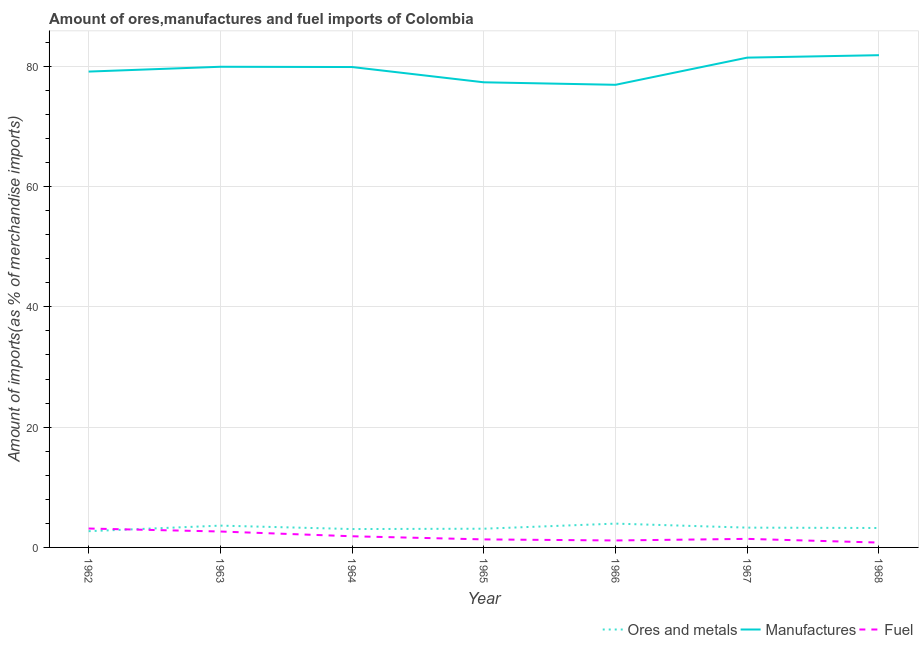How many different coloured lines are there?
Your response must be concise. 3. Does the line corresponding to percentage of fuel imports intersect with the line corresponding to percentage of manufactures imports?
Your response must be concise. No. What is the percentage of manufactures imports in 1967?
Give a very brief answer. 81.44. Across all years, what is the maximum percentage of manufactures imports?
Provide a short and direct response. 81.84. Across all years, what is the minimum percentage of manufactures imports?
Ensure brevity in your answer.  76.92. In which year was the percentage of ores and metals imports maximum?
Keep it short and to the point. 1966. In which year was the percentage of ores and metals imports minimum?
Your response must be concise. 1962. What is the total percentage of ores and metals imports in the graph?
Offer a very short reply. 22.97. What is the difference between the percentage of fuel imports in 1962 and that in 1964?
Give a very brief answer. 1.29. What is the difference between the percentage of ores and metals imports in 1962 and the percentage of manufactures imports in 1966?
Your answer should be very brief. -74.22. What is the average percentage of manufactures imports per year?
Your response must be concise. 79.49. In the year 1966, what is the difference between the percentage of fuel imports and percentage of manufactures imports?
Provide a short and direct response. -75.76. What is the ratio of the percentage of ores and metals imports in 1964 to that in 1966?
Your answer should be compact. 0.77. Is the percentage of fuel imports in 1962 less than that in 1965?
Provide a succinct answer. No. Is the difference between the percentage of ores and metals imports in 1964 and 1965 greater than the difference between the percentage of fuel imports in 1964 and 1965?
Ensure brevity in your answer.  No. What is the difference between the highest and the second highest percentage of manufactures imports?
Your response must be concise. 0.4. What is the difference between the highest and the lowest percentage of ores and metals imports?
Offer a very short reply. 1.26. How many lines are there?
Make the answer very short. 3. Does the graph contain grids?
Offer a terse response. Yes. How many legend labels are there?
Give a very brief answer. 3. What is the title of the graph?
Your response must be concise. Amount of ores,manufactures and fuel imports of Colombia. Does "Poland" appear as one of the legend labels in the graph?
Make the answer very short. No. What is the label or title of the Y-axis?
Provide a succinct answer. Amount of imports(as % of merchandise imports). What is the Amount of imports(as % of merchandise imports) in Ores and metals in 1962?
Keep it short and to the point. 2.7. What is the Amount of imports(as % of merchandise imports) in Manufactures in 1962?
Your answer should be compact. 79.12. What is the Amount of imports(as % of merchandise imports) in Fuel in 1962?
Provide a short and direct response. 3.14. What is the Amount of imports(as % of merchandise imports) in Ores and metals in 1963?
Keep it short and to the point. 3.63. What is the Amount of imports(as % of merchandise imports) in Manufactures in 1963?
Offer a terse response. 79.92. What is the Amount of imports(as % of merchandise imports) of Fuel in 1963?
Your answer should be very brief. 2.65. What is the Amount of imports(as % of merchandise imports) in Ores and metals in 1964?
Provide a short and direct response. 3.06. What is the Amount of imports(as % of merchandise imports) in Manufactures in 1964?
Offer a very short reply. 79.87. What is the Amount of imports(as % of merchandise imports) in Fuel in 1964?
Your response must be concise. 1.86. What is the Amount of imports(as % of merchandise imports) in Ores and metals in 1965?
Offer a terse response. 3.11. What is the Amount of imports(as % of merchandise imports) in Manufactures in 1965?
Provide a short and direct response. 77.33. What is the Amount of imports(as % of merchandise imports) of Fuel in 1965?
Provide a short and direct response. 1.33. What is the Amount of imports(as % of merchandise imports) of Ores and metals in 1966?
Give a very brief answer. 3.96. What is the Amount of imports(as % of merchandise imports) in Manufactures in 1966?
Your answer should be compact. 76.92. What is the Amount of imports(as % of merchandise imports) of Fuel in 1966?
Offer a terse response. 1.16. What is the Amount of imports(as % of merchandise imports) of Ores and metals in 1967?
Keep it short and to the point. 3.29. What is the Amount of imports(as % of merchandise imports) of Manufactures in 1967?
Provide a short and direct response. 81.44. What is the Amount of imports(as % of merchandise imports) of Fuel in 1967?
Provide a short and direct response. 1.42. What is the Amount of imports(as % of merchandise imports) in Ores and metals in 1968?
Provide a succinct answer. 3.23. What is the Amount of imports(as % of merchandise imports) in Manufactures in 1968?
Offer a very short reply. 81.84. What is the Amount of imports(as % of merchandise imports) of Fuel in 1968?
Offer a very short reply. 0.81. Across all years, what is the maximum Amount of imports(as % of merchandise imports) of Ores and metals?
Offer a terse response. 3.96. Across all years, what is the maximum Amount of imports(as % of merchandise imports) of Manufactures?
Offer a very short reply. 81.84. Across all years, what is the maximum Amount of imports(as % of merchandise imports) of Fuel?
Your response must be concise. 3.14. Across all years, what is the minimum Amount of imports(as % of merchandise imports) in Ores and metals?
Keep it short and to the point. 2.7. Across all years, what is the minimum Amount of imports(as % of merchandise imports) in Manufactures?
Provide a succinct answer. 76.92. Across all years, what is the minimum Amount of imports(as % of merchandise imports) of Fuel?
Provide a succinct answer. 0.81. What is the total Amount of imports(as % of merchandise imports) in Ores and metals in the graph?
Offer a very short reply. 22.97. What is the total Amount of imports(as % of merchandise imports) in Manufactures in the graph?
Provide a short and direct response. 556.45. What is the total Amount of imports(as % of merchandise imports) in Fuel in the graph?
Provide a succinct answer. 12.37. What is the difference between the Amount of imports(as % of merchandise imports) of Ores and metals in 1962 and that in 1963?
Your answer should be very brief. -0.92. What is the difference between the Amount of imports(as % of merchandise imports) in Manufactures in 1962 and that in 1963?
Your answer should be compact. -0.8. What is the difference between the Amount of imports(as % of merchandise imports) of Fuel in 1962 and that in 1963?
Your response must be concise. 0.5. What is the difference between the Amount of imports(as % of merchandise imports) in Ores and metals in 1962 and that in 1964?
Offer a terse response. -0.35. What is the difference between the Amount of imports(as % of merchandise imports) of Manufactures in 1962 and that in 1964?
Give a very brief answer. -0.76. What is the difference between the Amount of imports(as % of merchandise imports) of Fuel in 1962 and that in 1964?
Your answer should be compact. 1.29. What is the difference between the Amount of imports(as % of merchandise imports) in Ores and metals in 1962 and that in 1965?
Keep it short and to the point. -0.41. What is the difference between the Amount of imports(as % of merchandise imports) of Manufactures in 1962 and that in 1965?
Provide a short and direct response. 1.78. What is the difference between the Amount of imports(as % of merchandise imports) in Fuel in 1962 and that in 1965?
Offer a terse response. 1.81. What is the difference between the Amount of imports(as % of merchandise imports) in Ores and metals in 1962 and that in 1966?
Give a very brief answer. -1.26. What is the difference between the Amount of imports(as % of merchandise imports) in Manufactures in 1962 and that in 1966?
Your answer should be compact. 2.2. What is the difference between the Amount of imports(as % of merchandise imports) in Fuel in 1962 and that in 1966?
Offer a very short reply. 1.99. What is the difference between the Amount of imports(as % of merchandise imports) in Ores and metals in 1962 and that in 1967?
Offer a terse response. -0.59. What is the difference between the Amount of imports(as % of merchandise imports) in Manufactures in 1962 and that in 1967?
Provide a succinct answer. -2.32. What is the difference between the Amount of imports(as % of merchandise imports) of Fuel in 1962 and that in 1967?
Provide a succinct answer. 1.72. What is the difference between the Amount of imports(as % of merchandise imports) in Ores and metals in 1962 and that in 1968?
Ensure brevity in your answer.  -0.53. What is the difference between the Amount of imports(as % of merchandise imports) of Manufactures in 1962 and that in 1968?
Ensure brevity in your answer.  -2.72. What is the difference between the Amount of imports(as % of merchandise imports) in Fuel in 1962 and that in 1968?
Make the answer very short. 2.34. What is the difference between the Amount of imports(as % of merchandise imports) of Ores and metals in 1963 and that in 1964?
Keep it short and to the point. 0.57. What is the difference between the Amount of imports(as % of merchandise imports) of Manufactures in 1963 and that in 1964?
Ensure brevity in your answer.  0.04. What is the difference between the Amount of imports(as % of merchandise imports) of Fuel in 1963 and that in 1964?
Offer a very short reply. 0.79. What is the difference between the Amount of imports(as % of merchandise imports) of Ores and metals in 1963 and that in 1965?
Make the answer very short. 0.51. What is the difference between the Amount of imports(as % of merchandise imports) of Manufactures in 1963 and that in 1965?
Your answer should be compact. 2.58. What is the difference between the Amount of imports(as % of merchandise imports) in Fuel in 1963 and that in 1965?
Offer a very short reply. 1.31. What is the difference between the Amount of imports(as % of merchandise imports) of Ores and metals in 1963 and that in 1966?
Offer a terse response. -0.33. What is the difference between the Amount of imports(as % of merchandise imports) in Manufactures in 1963 and that in 1966?
Offer a very short reply. 3. What is the difference between the Amount of imports(as % of merchandise imports) in Fuel in 1963 and that in 1966?
Provide a succinct answer. 1.49. What is the difference between the Amount of imports(as % of merchandise imports) in Ores and metals in 1963 and that in 1967?
Your response must be concise. 0.34. What is the difference between the Amount of imports(as % of merchandise imports) of Manufactures in 1963 and that in 1967?
Ensure brevity in your answer.  -1.52. What is the difference between the Amount of imports(as % of merchandise imports) in Fuel in 1963 and that in 1967?
Your answer should be very brief. 1.22. What is the difference between the Amount of imports(as % of merchandise imports) in Ores and metals in 1963 and that in 1968?
Provide a short and direct response. 0.4. What is the difference between the Amount of imports(as % of merchandise imports) in Manufactures in 1963 and that in 1968?
Your answer should be very brief. -1.92. What is the difference between the Amount of imports(as % of merchandise imports) of Fuel in 1963 and that in 1968?
Provide a succinct answer. 1.84. What is the difference between the Amount of imports(as % of merchandise imports) of Ores and metals in 1964 and that in 1965?
Offer a very short reply. -0.06. What is the difference between the Amount of imports(as % of merchandise imports) in Manufactures in 1964 and that in 1965?
Provide a short and direct response. 2.54. What is the difference between the Amount of imports(as % of merchandise imports) in Fuel in 1964 and that in 1965?
Your answer should be very brief. 0.52. What is the difference between the Amount of imports(as % of merchandise imports) of Ores and metals in 1964 and that in 1966?
Provide a short and direct response. -0.9. What is the difference between the Amount of imports(as % of merchandise imports) of Manufactures in 1964 and that in 1966?
Your response must be concise. 2.95. What is the difference between the Amount of imports(as % of merchandise imports) in Fuel in 1964 and that in 1966?
Ensure brevity in your answer.  0.7. What is the difference between the Amount of imports(as % of merchandise imports) in Ores and metals in 1964 and that in 1967?
Provide a short and direct response. -0.23. What is the difference between the Amount of imports(as % of merchandise imports) in Manufactures in 1964 and that in 1967?
Ensure brevity in your answer.  -1.57. What is the difference between the Amount of imports(as % of merchandise imports) of Fuel in 1964 and that in 1967?
Keep it short and to the point. 0.43. What is the difference between the Amount of imports(as % of merchandise imports) of Ores and metals in 1964 and that in 1968?
Offer a terse response. -0.17. What is the difference between the Amount of imports(as % of merchandise imports) in Manufactures in 1964 and that in 1968?
Offer a terse response. -1.97. What is the difference between the Amount of imports(as % of merchandise imports) of Fuel in 1964 and that in 1968?
Your response must be concise. 1.05. What is the difference between the Amount of imports(as % of merchandise imports) in Ores and metals in 1965 and that in 1966?
Keep it short and to the point. -0.85. What is the difference between the Amount of imports(as % of merchandise imports) of Manufactures in 1965 and that in 1966?
Your response must be concise. 0.42. What is the difference between the Amount of imports(as % of merchandise imports) of Fuel in 1965 and that in 1966?
Your answer should be compact. 0.18. What is the difference between the Amount of imports(as % of merchandise imports) of Ores and metals in 1965 and that in 1967?
Provide a short and direct response. -0.18. What is the difference between the Amount of imports(as % of merchandise imports) of Manufactures in 1965 and that in 1967?
Make the answer very short. -4.1. What is the difference between the Amount of imports(as % of merchandise imports) in Fuel in 1965 and that in 1967?
Make the answer very short. -0.09. What is the difference between the Amount of imports(as % of merchandise imports) of Ores and metals in 1965 and that in 1968?
Your answer should be very brief. -0.12. What is the difference between the Amount of imports(as % of merchandise imports) in Manufactures in 1965 and that in 1968?
Give a very brief answer. -4.51. What is the difference between the Amount of imports(as % of merchandise imports) in Fuel in 1965 and that in 1968?
Offer a terse response. 0.53. What is the difference between the Amount of imports(as % of merchandise imports) in Ores and metals in 1966 and that in 1967?
Your response must be concise. 0.67. What is the difference between the Amount of imports(as % of merchandise imports) in Manufactures in 1966 and that in 1967?
Give a very brief answer. -4.52. What is the difference between the Amount of imports(as % of merchandise imports) in Fuel in 1966 and that in 1967?
Your answer should be compact. -0.27. What is the difference between the Amount of imports(as % of merchandise imports) in Ores and metals in 1966 and that in 1968?
Offer a very short reply. 0.73. What is the difference between the Amount of imports(as % of merchandise imports) of Manufactures in 1966 and that in 1968?
Provide a succinct answer. -4.92. What is the difference between the Amount of imports(as % of merchandise imports) of Fuel in 1966 and that in 1968?
Provide a short and direct response. 0.35. What is the difference between the Amount of imports(as % of merchandise imports) in Ores and metals in 1967 and that in 1968?
Provide a succinct answer. 0.06. What is the difference between the Amount of imports(as % of merchandise imports) of Manufactures in 1967 and that in 1968?
Give a very brief answer. -0.4. What is the difference between the Amount of imports(as % of merchandise imports) of Fuel in 1967 and that in 1968?
Provide a succinct answer. 0.62. What is the difference between the Amount of imports(as % of merchandise imports) of Ores and metals in 1962 and the Amount of imports(as % of merchandise imports) of Manufactures in 1963?
Your answer should be very brief. -77.22. What is the difference between the Amount of imports(as % of merchandise imports) of Ores and metals in 1962 and the Amount of imports(as % of merchandise imports) of Fuel in 1963?
Provide a short and direct response. 0.06. What is the difference between the Amount of imports(as % of merchandise imports) of Manufactures in 1962 and the Amount of imports(as % of merchandise imports) of Fuel in 1963?
Your answer should be very brief. 76.47. What is the difference between the Amount of imports(as % of merchandise imports) of Ores and metals in 1962 and the Amount of imports(as % of merchandise imports) of Manufactures in 1964?
Ensure brevity in your answer.  -77.17. What is the difference between the Amount of imports(as % of merchandise imports) of Ores and metals in 1962 and the Amount of imports(as % of merchandise imports) of Fuel in 1964?
Ensure brevity in your answer.  0.84. What is the difference between the Amount of imports(as % of merchandise imports) of Manufactures in 1962 and the Amount of imports(as % of merchandise imports) of Fuel in 1964?
Provide a short and direct response. 77.26. What is the difference between the Amount of imports(as % of merchandise imports) in Ores and metals in 1962 and the Amount of imports(as % of merchandise imports) in Manufactures in 1965?
Your answer should be compact. -74.63. What is the difference between the Amount of imports(as % of merchandise imports) of Ores and metals in 1962 and the Amount of imports(as % of merchandise imports) of Fuel in 1965?
Keep it short and to the point. 1.37. What is the difference between the Amount of imports(as % of merchandise imports) in Manufactures in 1962 and the Amount of imports(as % of merchandise imports) in Fuel in 1965?
Offer a terse response. 77.78. What is the difference between the Amount of imports(as % of merchandise imports) in Ores and metals in 1962 and the Amount of imports(as % of merchandise imports) in Manufactures in 1966?
Provide a short and direct response. -74.22. What is the difference between the Amount of imports(as % of merchandise imports) of Ores and metals in 1962 and the Amount of imports(as % of merchandise imports) of Fuel in 1966?
Provide a succinct answer. 1.54. What is the difference between the Amount of imports(as % of merchandise imports) in Manufactures in 1962 and the Amount of imports(as % of merchandise imports) in Fuel in 1966?
Make the answer very short. 77.96. What is the difference between the Amount of imports(as % of merchandise imports) of Ores and metals in 1962 and the Amount of imports(as % of merchandise imports) of Manufactures in 1967?
Your answer should be very brief. -78.74. What is the difference between the Amount of imports(as % of merchandise imports) in Ores and metals in 1962 and the Amount of imports(as % of merchandise imports) in Fuel in 1967?
Ensure brevity in your answer.  1.28. What is the difference between the Amount of imports(as % of merchandise imports) in Manufactures in 1962 and the Amount of imports(as % of merchandise imports) in Fuel in 1967?
Your response must be concise. 77.7. What is the difference between the Amount of imports(as % of merchandise imports) of Ores and metals in 1962 and the Amount of imports(as % of merchandise imports) of Manufactures in 1968?
Offer a very short reply. -79.14. What is the difference between the Amount of imports(as % of merchandise imports) in Ores and metals in 1962 and the Amount of imports(as % of merchandise imports) in Fuel in 1968?
Keep it short and to the point. 1.89. What is the difference between the Amount of imports(as % of merchandise imports) of Manufactures in 1962 and the Amount of imports(as % of merchandise imports) of Fuel in 1968?
Your answer should be compact. 78.31. What is the difference between the Amount of imports(as % of merchandise imports) in Ores and metals in 1963 and the Amount of imports(as % of merchandise imports) in Manufactures in 1964?
Make the answer very short. -76.25. What is the difference between the Amount of imports(as % of merchandise imports) of Ores and metals in 1963 and the Amount of imports(as % of merchandise imports) of Fuel in 1964?
Ensure brevity in your answer.  1.77. What is the difference between the Amount of imports(as % of merchandise imports) in Manufactures in 1963 and the Amount of imports(as % of merchandise imports) in Fuel in 1964?
Provide a short and direct response. 78.06. What is the difference between the Amount of imports(as % of merchandise imports) of Ores and metals in 1963 and the Amount of imports(as % of merchandise imports) of Manufactures in 1965?
Your answer should be very brief. -73.71. What is the difference between the Amount of imports(as % of merchandise imports) in Ores and metals in 1963 and the Amount of imports(as % of merchandise imports) in Fuel in 1965?
Give a very brief answer. 2.29. What is the difference between the Amount of imports(as % of merchandise imports) in Manufactures in 1963 and the Amount of imports(as % of merchandise imports) in Fuel in 1965?
Provide a short and direct response. 78.58. What is the difference between the Amount of imports(as % of merchandise imports) in Ores and metals in 1963 and the Amount of imports(as % of merchandise imports) in Manufactures in 1966?
Keep it short and to the point. -73.29. What is the difference between the Amount of imports(as % of merchandise imports) in Ores and metals in 1963 and the Amount of imports(as % of merchandise imports) in Fuel in 1966?
Keep it short and to the point. 2.47. What is the difference between the Amount of imports(as % of merchandise imports) in Manufactures in 1963 and the Amount of imports(as % of merchandise imports) in Fuel in 1966?
Provide a succinct answer. 78.76. What is the difference between the Amount of imports(as % of merchandise imports) of Ores and metals in 1963 and the Amount of imports(as % of merchandise imports) of Manufactures in 1967?
Offer a very short reply. -77.81. What is the difference between the Amount of imports(as % of merchandise imports) in Ores and metals in 1963 and the Amount of imports(as % of merchandise imports) in Fuel in 1967?
Make the answer very short. 2.2. What is the difference between the Amount of imports(as % of merchandise imports) of Manufactures in 1963 and the Amount of imports(as % of merchandise imports) of Fuel in 1967?
Make the answer very short. 78.5. What is the difference between the Amount of imports(as % of merchandise imports) of Ores and metals in 1963 and the Amount of imports(as % of merchandise imports) of Manufactures in 1968?
Provide a short and direct response. -78.22. What is the difference between the Amount of imports(as % of merchandise imports) in Ores and metals in 1963 and the Amount of imports(as % of merchandise imports) in Fuel in 1968?
Your answer should be compact. 2.82. What is the difference between the Amount of imports(as % of merchandise imports) in Manufactures in 1963 and the Amount of imports(as % of merchandise imports) in Fuel in 1968?
Offer a terse response. 79.11. What is the difference between the Amount of imports(as % of merchandise imports) in Ores and metals in 1964 and the Amount of imports(as % of merchandise imports) in Manufactures in 1965?
Offer a terse response. -74.28. What is the difference between the Amount of imports(as % of merchandise imports) in Ores and metals in 1964 and the Amount of imports(as % of merchandise imports) in Fuel in 1965?
Ensure brevity in your answer.  1.72. What is the difference between the Amount of imports(as % of merchandise imports) in Manufactures in 1964 and the Amount of imports(as % of merchandise imports) in Fuel in 1965?
Offer a terse response. 78.54. What is the difference between the Amount of imports(as % of merchandise imports) in Ores and metals in 1964 and the Amount of imports(as % of merchandise imports) in Manufactures in 1966?
Your answer should be very brief. -73.86. What is the difference between the Amount of imports(as % of merchandise imports) in Ores and metals in 1964 and the Amount of imports(as % of merchandise imports) in Fuel in 1966?
Make the answer very short. 1.9. What is the difference between the Amount of imports(as % of merchandise imports) of Manufactures in 1964 and the Amount of imports(as % of merchandise imports) of Fuel in 1966?
Provide a succinct answer. 78.72. What is the difference between the Amount of imports(as % of merchandise imports) of Ores and metals in 1964 and the Amount of imports(as % of merchandise imports) of Manufactures in 1967?
Your answer should be compact. -78.38. What is the difference between the Amount of imports(as % of merchandise imports) in Ores and metals in 1964 and the Amount of imports(as % of merchandise imports) in Fuel in 1967?
Provide a succinct answer. 1.63. What is the difference between the Amount of imports(as % of merchandise imports) of Manufactures in 1964 and the Amount of imports(as % of merchandise imports) of Fuel in 1967?
Your response must be concise. 78.45. What is the difference between the Amount of imports(as % of merchandise imports) in Ores and metals in 1964 and the Amount of imports(as % of merchandise imports) in Manufactures in 1968?
Provide a succinct answer. -78.79. What is the difference between the Amount of imports(as % of merchandise imports) in Ores and metals in 1964 and the Amount of imports(as % of merchandise imports) in Fuel in 1968?
Your answer should be very brief. 2.25. What is the difference between the Amount of imports(as % of merchandise imports) of Manufactures in 1964 and the Amount of imports(as % of merchandise imports) of Fuel in 1968?
Give a very brief answer. 79.07. What is the difference between the Amount of imports(as % of merchandise imports) of Ores and metals in 1965 and the Amount of imports(as % of merchandise imports) of Manufactures in 1966?
Ensure brevity in your answer.  -73.81. What is the difference between the Amount of imports(as % of merchandise imports) of Ores and metals in 1965 and the Amount of imports(as % of merchandise imports) of Fuel in 1966?
Make the answer very short. 1.95. What is the difference between the Amount of imports(as % of merchandise imports) in Manufactures in 1965 and the Amount of imports(as % of merchandise imports) in Fuel in 1966?
Keep it short and to the point. 76.18. What is the difference between the Amount of imports(as % of merchandise imports) in Ores and metals in 1965 and the Amount of imports(as % of merchandise imports) in Manufactures in 1967?
Offer a terse response. -78.33. What is the difference between the Amount of imports(as % of merchandise imports) of Ores and metals in 1965 and the Amount of imports(as % of merchandise imports) of Fuel in 1967?
Provide a succinct answer. 1.69. What is the difference between the Amount of imports(as % of merchandise imports) of Manufactures in 1965 and the Amount of imports(as % of merchandise imports) of Fuel in 1967?
Offer a terse response. 75.91. What is the difference between the Amount of imports(as % of merchandise imports) of Ores and metals in 1965 and the Amount of imports(as % of merchandise imports) of Manufactures in 1968?
Provide a short and direct response. -78.73. What is the difference between the Amount of imports(as % of merchandise imports) of Ores and metals in 1965 and the Amount of imports(as % of merchandise imports) of Fuel in 1968?
Your answer should be very brief. 2.3. What is the difference between the Amount of imports(as % of merchandise imports) of Manufactures in 1965 and the Amount of imports(as % of merchandise imports) of Fuel in 1968?
Provide a short and direct response. 76.53. What is the difference between the Amount of imports(as % of merchandise imports) in Ores and metals in 1966 and the Amount of imports(as % of merchandise imports) in Manufactures in 1967?
Make the answer very short. -77.48. What is the difference between the Amount of imports(as % of merchandise imports) of Ores and metals in 1966 and the Amount of imports(as % of merchandise imports) of Fuel in 1967?
Offer a very short reply. 2.54. What is the difference between the Amount of imports(as % of merchandise imports) of Manufactures in 1966 and the Amount of imports(as % of merchandise imports) of Fuel in 1967?
Your answer should be compact. 75.5. What is the difference between the Amount of imports(as % of merchandise imports) of Ores and metals in 1966 and the Amount of imports(as % of merchandise imports) of Manufactures in 1968?
Make the answer very short. -77.88. What is the difference between the Amount of imports(as % of merchandise imports) of Ores and metals in 1966 and the Amount of imports(as % of merchandise imports) of Fuel in 1968?
Your answer should be very brief. 3.15. What is the difference between the Amount of imports(as % of merchandise imports) in Manufactures in 1966 and the Amount of imports(as % of merchandise imports) in Fuel in 1968?
Make the answer very short. 76.11. What is the difference between the Amount of imports(as % of merchandise imports) of Ores and metals in 1967 and the Amount of imports(as % of merchandise imports) of Manufactures in 1968?
Ensure brevity in your answer.  -78.55. What is the difference between the Amount of imports(as % of merchandise imports) in Ores and metals in 1967 and the Amount of imports(as % of merchandise imports) in Fuel in 1968?
Ensure brevity in your answer.  2.48. What is the difference between the Amount of imports(as % of merchandise imports) in Manufactures in 1967 and the Amount of imports(as % of merchandise imports) in Fuel in 1968?
Your response must be concise. 80.63. What is the average Amount of imports(as % of merchandise imports) in Ores and metals per year?
Your answer should be compact. 3.28. What is the average Amount of imports(as % of merchandise imports) in Manufactures per year?
Your response must be concise. 79.49. What is the average Amount of imports(as % of merchandise imports) of Fuel per year?
Your answer should be compact. 1.77. In the year 1962, what is the difference between the Amount of imports(as % of merchandise imports) of Ores and metals and Amount of imports(as % of merchandise imports) of Manufactures?
Keep it short and to the point. -76.42. In the year 1962, what is the difference between the Amount of imports(as % of merchandise imports) in Ores and metals and Amount of imports(as % of merchandise imports) in Fuel?
Provide a short and direct response. -0.44. In the year 1962, what is the difference between the Amount of imports(as % of merchandise imports) in Manufactures and Amount of imports(as % of merchandise imports) in Fuel?
Your answer should be compact. 75.98. In the year 1963, what is the difference between the Amount of imports(as % of merchandise imports) of Ores and metals and Amount of imports(as % of merchandise imports) of Manufactures?
Offer a terse response. -76.29. In the year 1963, what is the difference between the Amount of imports(as % of merchandise imports) of Ores and metals and Amount of imports(as % of merchandise imports) of Fuel?
Keep it short and to the point. 0.98. In the year 1963, what is the difference between the Amount of imports(as % of merchandise imports) of Manufactures and Amount of imports(as % of merchandise imports) of Fuel?
Keep it short and to the point. 77.27. In the year 1964, what is the difference between the Amount of imports(as % of merchandise imports) of Ores and metals and Amount of imports(as % of merchandise imports) of Manufactures?
Give a very brief answer. -76.82. In the year 1964, what is the difference between the Amount of imports(as % of merchandise imports) of Ores and metals and Amount of imports(as % of merchandise imports) of Fuel?
Make the answer very short. 1.2. In the year 1964, what is the difference between the Amount of imports(as % of merchandise imports) of Manufactures and Amount of imports(as % of merchandise imports) of Fuel?
Offer a terse response. 78.02. In the year 1965, what is the difference between the Amount of imports(as % of merchandise imports) in Ores and metals and Amount of imports(as % of merchandise imports) in Manufactures?
Your answer should be very brief. -74.22. In the year 1965, what is the difference between the Amount of imports(as % of merchandise imports) of Ores and metals and Amount of imports(as % of merchandise imports) of Fuel?
Provide a short and direct response. 1.78. In the year 1965, what is the difference between the Amount of imports(as % of merchandise imports) in Manufactures and Amount of imports(as % of merchandise imports) in Fuel?
Give a very brief answer. 76. In the year 1966, what is the difference between the Amount of imports(as % of merchandise imports) of Ores and metals and Amount of imports(as % of merchandise imports) of Manufactures?
Your answer should be compact. -72.96. In the year 1966, what is the difference between the Amount of imports(as % of merchandise imports) in Ores and metals and Amount of imports(as % of merchandise imports) in Fuel?
Keep it short and to the point. 2.8. In the year 1966, what is the difference between the Amount of imports(as % of merchandise imports) of Manufactures and Amount of imports(as % of merchandise imports) of Fuel?
Make the answer very short. 75.76. In the year 1967, what is the difference between the Amount of imports(as % of merchandise imports) of Ores and metals and Amount of imports(as % of merchandise imports) of Manufactures?
Give a very brief answer. -78.15. In the year 1967, what is the difference between the Amount of imports(as % of merchandise imports) in Ores and metals and Amount of imports(as % of merchandise imports) in Fuel?
Offer a terse response. 1.87. In the year 1967, what is the difference between the Amount of imports(as % of merchandise imports) of Manufactures and Amount of imports(as % of merchandise imports) of Fuel?
Keep it short and to the point. 80.02. In the year 1968, what is the difference between the Amount of imports(as % of merchandise imports) of Ores and metals and Amount of imports(as % of merchandise imports) of Manufactures?
Provide a short and direct response. -78.61. In the year 1968, what is the difference between the Amount of imports(as % of merchandise imports) in Ores and metals and Amount of imports(as % of merchandise imports) in Fuel?
Offer a terse response. 2.42. In the year 1968, what is the difference between the Amount of imports(as % of merchandise imports) in Manufactures and Amount of imports(as % of merchandise imports) in Fuel?
Offer a very short reply. 81.04. What is the ratio of the Amount of imports(as % of merchandise imports) of Ores and metals in 1962 to that in 1963?
Offer a very short reply. 0.75. What is the ratio of the Amount of imports(as % of merchandise imports) of Fuel in 1962 to that in 1963?
Your answer should be very brief. 1.19. What is the ratio of the Amount of imports(as % of merchandise imports) of Ores and metals in 1962 to that in 1964?
Your answer should be very brief. 0.88. What is the ratio of the Amount of imports(as % of merchandise imports) in Manufactures in 1962 to that in 1964?
Offer a terse response. 0.99. What is the ratio of the Amount of imports(as % of merchandise imports) in Fuel in 1962 to that in 1964?
Your answer should be very brief. 1.69. What is the ratio of the Amount of imports(as % of merchandise imports) in Ores and metals in 1962 to that in 1965?
Provide a short and direct response. 0.87. What is the ratio of the Amount of imports(as % of merchandise imports) in Manufactures in 1962 to that in 1965?
Your answer should be very brief. 1.02. What is the ratio of the Amount of imports(as % of merchandise imports) of Fuel in 1962 to that in 1965?
Offer a very short reply. 2.36. What is the ratio of the Amount of imports(as % of merchandise imports) in Ores and metals in 1962 to that in 1966?
Provide a short and direct response. 0.68. What is the ratio of the Amount of imports(as % of merchandise imports) of Manufactures in 1962 to that in 1966?
Keep it short and to the point. 1.03. What is the ratio of the Amount of imports(as % of merchandise imports) of Fuel in 1962 to that in 1966?
Keep it short and to the point. 2.72. What is the ratio of the Amount of imports(as % of merchandise imports) in Ores and metals in 1962 to that in 1967?
Your answer should be compact. 0.82. What is the ratio of the Amount of imports(as % of merchandise imports) of Manufactures in 1962 to that in 1967?
Provide a succinct answer. 0.97. What is the ratio of the Amount of imports(as % of merchandise imports) in Fuel in 1962 to that in 1967?
Provide a succinct answer. 2.21. What is the ratio of the Amount of imports(as % of merchandise imports) of Ores and metals in 1962 to that in 1968?
Offer a very short reply. 0.84. What is the ratio of the Amount of imports(as % of merchandise imports) of Manufactures in 1962 to that in 1968?
Keep it short and to the point. 0.97. What is the ratio of the Amount of imports(as % of merchandise imports) of Fuel in 1962 to that in 1968?
Offer a very short reply. 3.9. What is the ratio of the Amount of imports(as % of merchandise imports) of Ores and metals in 1963 to that in 1964?
Your response must be concise. 1.19. What is the ratio of the Amount of imports(as % of merchandise imports) in Fuel in 1963 to that in 1964?
Ensure brevity in your answer.  1.43. What is the ratio of the Amount of imports(as % of merchandise imports) in Ores and metals in 1963 to that in 1965?
Provide a succinct answer. 1.17. What is the ratio of the Amount of imports(as % of merchandise imports) of Manufactures in 1963 to that in 1965?
Give a very brief answer. 1.03. What is the ratio of the Amount of imports(as % of merchandise imports) of Fuel in 1963 to that in 1965?
Keep it short and to the point. 1.98. What is the ratio of the Amount of imports(as % of merchandise imports) in Ores and metals in 1963 to that in 1966?
Offer a very short reply. 0.92. What is the ratio of the Amount of imports(as % of merchandise imports) in Manufactures in 1963 to that in 1966?
Make the answer very short. 1.04. What is the ratio of the Amount of imports(as % of merchandise imports) of Fuel in 1963 to that in 1966?
Offer a very short reply. 2.29. What is the ratio of the Amount of imports(as % of merchandise imports) in Ores and metals in 1963 to that in 1967?
Your answer should be compact. 1.1. What is the ratio of the Amount of imports(as % of merchandise imports) of Manufactures in 1963 to that in 1967?
Your answer should be very brief. 0.98. What is the ratio of the Amount of imports(as % of merchandise imports) in Fuel in 1963 to that in 1967?
Give a very brief answer. 1.86. What is the ratio of the Amount of imports(as % of merchandise imports) of Ores and metals in 1963 to that in 1968?
Provide a succinct answer. 1.12. What is the ratio of the Amount of imports(as % of merchandise imports) of Manufactures in 1963 to that in 1968?
Ensure brevity in your answer.  0.98. What is the ratio of the Amount of imports(as % of merchandise imports) of Fuel in 1963 to that in 1968?
Provide a succinct answer. 3.28. What is the ratio of the Amount of imports(as % of merchandise imports) of Ores and metals in 1964 to that in 1965?
Offer a terse response. 0.98. What is the ratio of the Amount of imports(as % of merchandise imports) of Manufactures in 1964 to that in 1965?
Your answer should be compact. 1.03. What is the ratio of the Amount of imports(as % of merchandise imports) of Fuel in 1964 to that in 1965?
Provide a short and direct response. 1.39. What is the ratio of the Amount of imports(as % of merchandise imports) of Ores and metals in 1964 to that in 1966?
Offer a terse response. 0.77. What is the ratio of the Amount of imports(as % of merchandise imports) in Manufactures in 1964 to that in 1966?
Your answer should be compact. 1.04. What is the ratio of the Amount of imports(as % of merchandise imports) in Fuel in 1964 to that in 1966?
Offer a terse response. 1.6. What is the ratio of the Amount of imports(as % of merchandise imports) in Ores and metals in 1964 to that in 1967?
Offer a very short reply. 0.93. What is the ratio of the Amount of imports(as % of merchandise imports) of Manufactures in 1964 to that in 1967?
Provide a short and direct response. 0.98. What is the ratio of the Amount of imports(as % of merchandise imports) in Fuel in 1964 to that in 1967?
Ensure brevity in your answer.  1.3. What is the ratio of the Amount of imports(as % of merchandise imports) of Ores and metals in 1964 to that in 1968?
Provide a short and direct response. 0.95. What is the ratio of the Amount of imports(as % of merchandise imports) of Manufactures in 1964 to that in 1968?
Keep it short and to the point. 0.98. What is the ratio of the Amount of imports(as % of merchandise imports) of Fuel in 1964 to that in 1968?
Give a very brief answer. 2.3. What is the ratio of the Amount of imports(as % of merchandise imports) in Ores and metals in 1965 to that in 1966?
Make the answer very short. 0.79. What is the ratio of the Amount of imports(as % of merchandise imports) in Manufactures in 1965 to that in 1966?
Keep it short and to the point. 1.01. What is the ratio of the Amount of imports(as % of merchandise imports) in Fuel in 1965 to that in 1966?
Your answer should be compact. 1.15. What is the ratio of the Amount of imports(as % of merchandise imports) in Ores and metals in 1965 to that in 1967?
Your response must be concise. 0.95. What is the ratio of the Amount of imports(as % of merchandise imports) in Manufactures in 1965 to that in 1967?
Keep it short and to the point. 0.95. What is the ratio of the Amount of imports(as % of merchandise imports) of Fuel in 1965 to that in 1967?
Give a very brief answer. 0.94. What is the ratio of the Amount of imports(as % of merchandise imports) in Ores and metals in 1965 to that in 1968?
Offer a terse response. 0.96. What is the ratio of the Amount of imports(as % of merchandise imports) of Manufactures in 1965 to that in 1968?
Keep it short and to the point. 0.94. What is the ratio of the Amount of imports(as % of merchandise imports) in Fuel in 1965 to that in 1968?
Keep it short and to the point. 1.65. What is the ratio of the Amount of imports(as % of merchandise imports) in Ores and metals in 1966 to that in 1967?
Keep it short and to the point. 1.2. What is the ratio of the Amount of imports(as % of merchandise imports) of Manufactures in 1966 to that in 1967?
Keep it short and to the point. 0.94. What is the ratio of the Amount of imports(as % of merchandise imports) in Fuel in 1966 to that in 1967?
Give a very brief answer. 0.81. What is the ratio of the Amount of imports(as % of merchandise imports) of Ores and metals in 1966 to that in 1968?
Offer a terse response. 1.23. What is the ratio of the Amount of imports(as % of merchandise imports) of Manufactures in 1966 to that in 1968?
Make the answer very short. 0.94. What is the ratio of the Amount of imports(as % of merchandise imports) of Fuel in 1966 to that in 1968?
Ensure brevity in your answer.  1.43. What is the ratio of the Amount of imports(as % of merchandise imports) of Ores and metals in 1967 to that in 1968?
Offer a very short reply. 1.02. What is the ratio of the Amount of imports(as % of merchandise imports) in Fuel in 1967 to that in 1968?
Offer a very short reply. 1.76. What is the difference between the highest and the second highest Amount of imports(as % of merchandise imports) of Ores and metals?
Provide a short and direct response. 0.33. What is the difference between the highest and the second highest Amount of imports(as % of merchandise imports) of Manufactures?
Provide a short and direct response. 0.4. What is the difference between the highest and the second highest Amount of imports(as % of merchandise imports) in Fuel?
Give a very brief answer. 0.5. What is the difference between the highest and the lowest Amount of imports(as % of merchandise imports) of Ores and metals?
Your answer should be compact. 1.26. What is the difference between the highest and the lowest Amount of imports(as % of merchandise imports) of Manufactures?
Provide a succinct answer. 4.92. What is the difference between the highest and the lowest Amount of imports(as % of merchandise imports) in Fuel?
Your answer should be very brief. 2.34. 